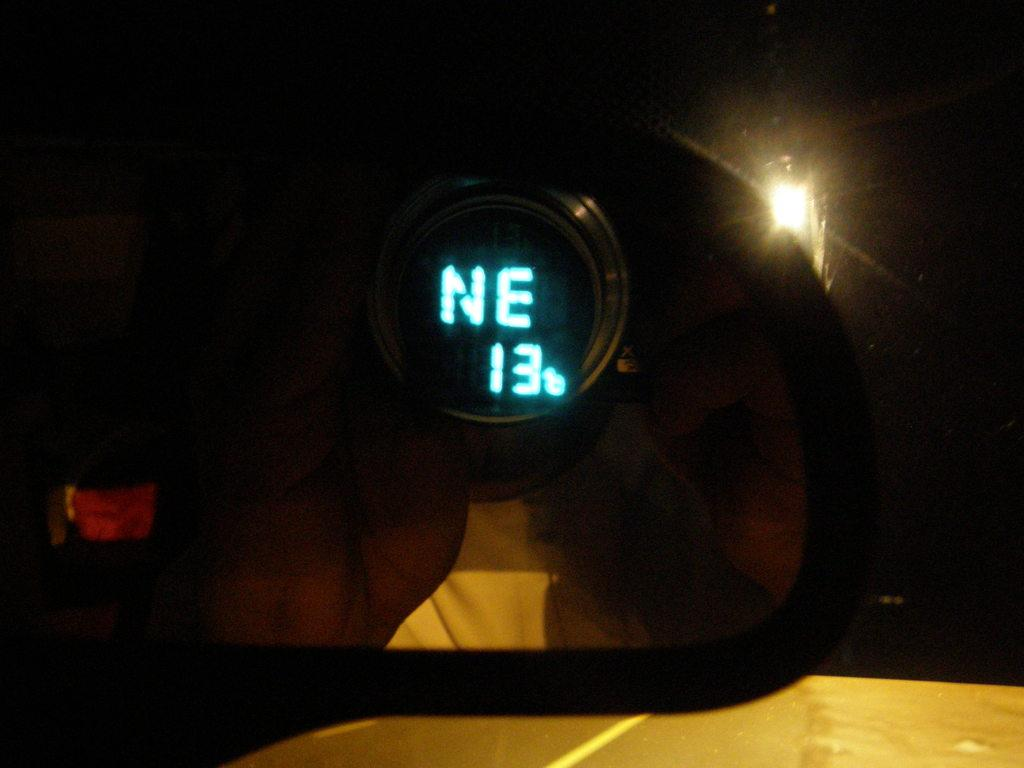What is the main subject of the image? The main subject of the image is a mirror of a vehicle. What can be seen in the mirror? Digital text is visible in the mirror. What other object is present on the ground in the image? There is a lamp post on the ground in the image. How many trees are present in the image? There are no trees visible in the image. What type of toys can be seen in the image? There are no toys present in the image. 